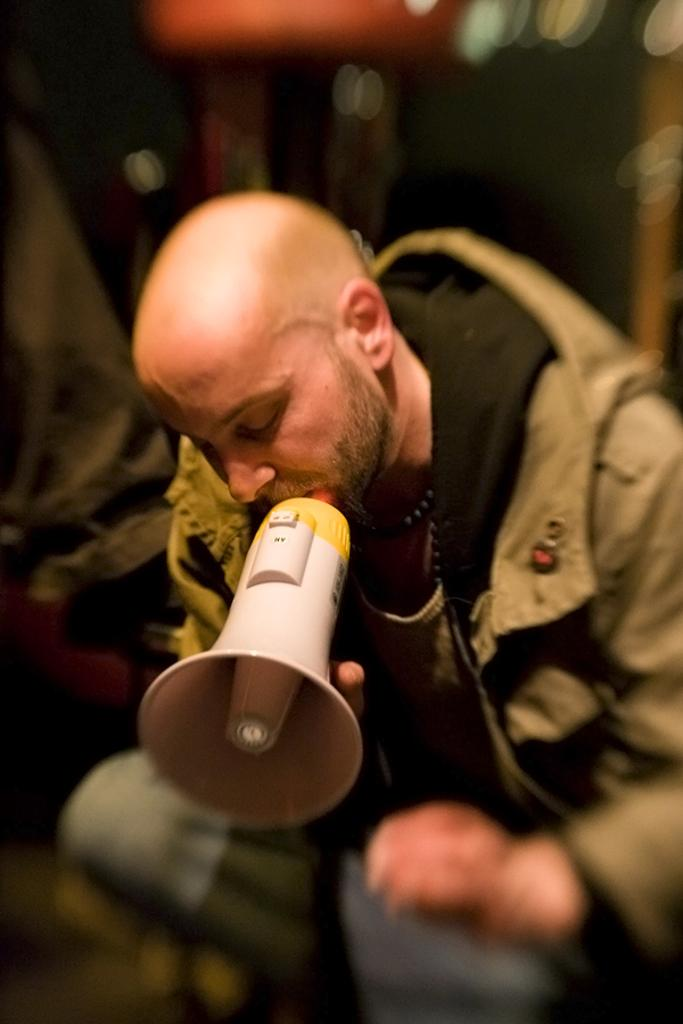Who is present in the image? There is a person in the image. What is the person holding in his hand? The person is holding a mic in his hand. What type of fuel is being used by the trucks in the image? There are no trucks present in the image, so it is not possible to determine the type of fuel being used. 